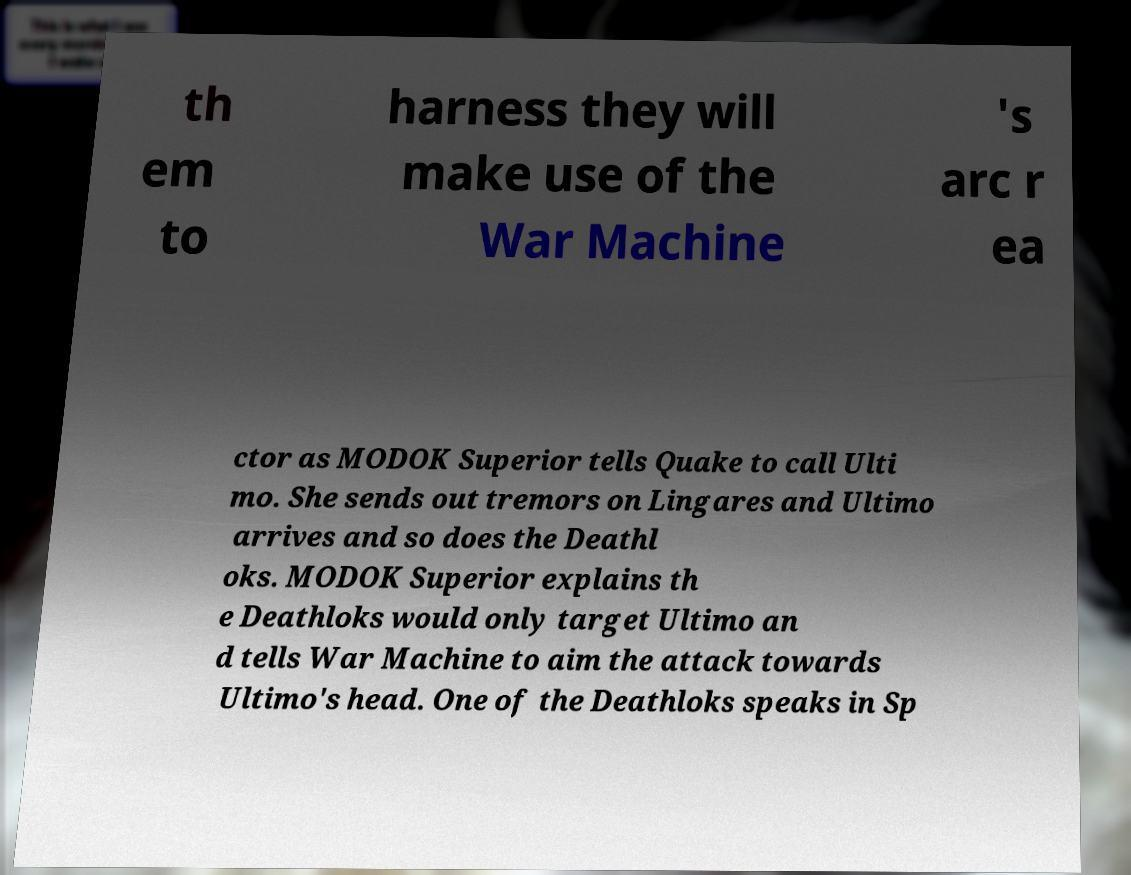I need the written content from this picture converted into text. Can you do that? th em to harness they will make use of the War Machine 's arc r ea ctor as MODOK Superior tells Quake to call Ulti mo. She sends out tremors on Lingares and Ultimo arrives and so does the Deathl oks. MODOK Superior explains th e Deathloks would only target Ultimo an d tells War Machine to aim the attack towards Ultimo's head. One of the Deathloks speaks in Sp 